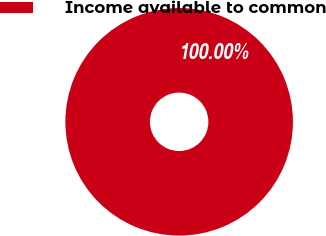Convert chart. <chart><loc_0><loc_0><loc_500><loc_500><pie_chart><fcel>Income available to common<nl><fcel>100.0%<nl></chart> 